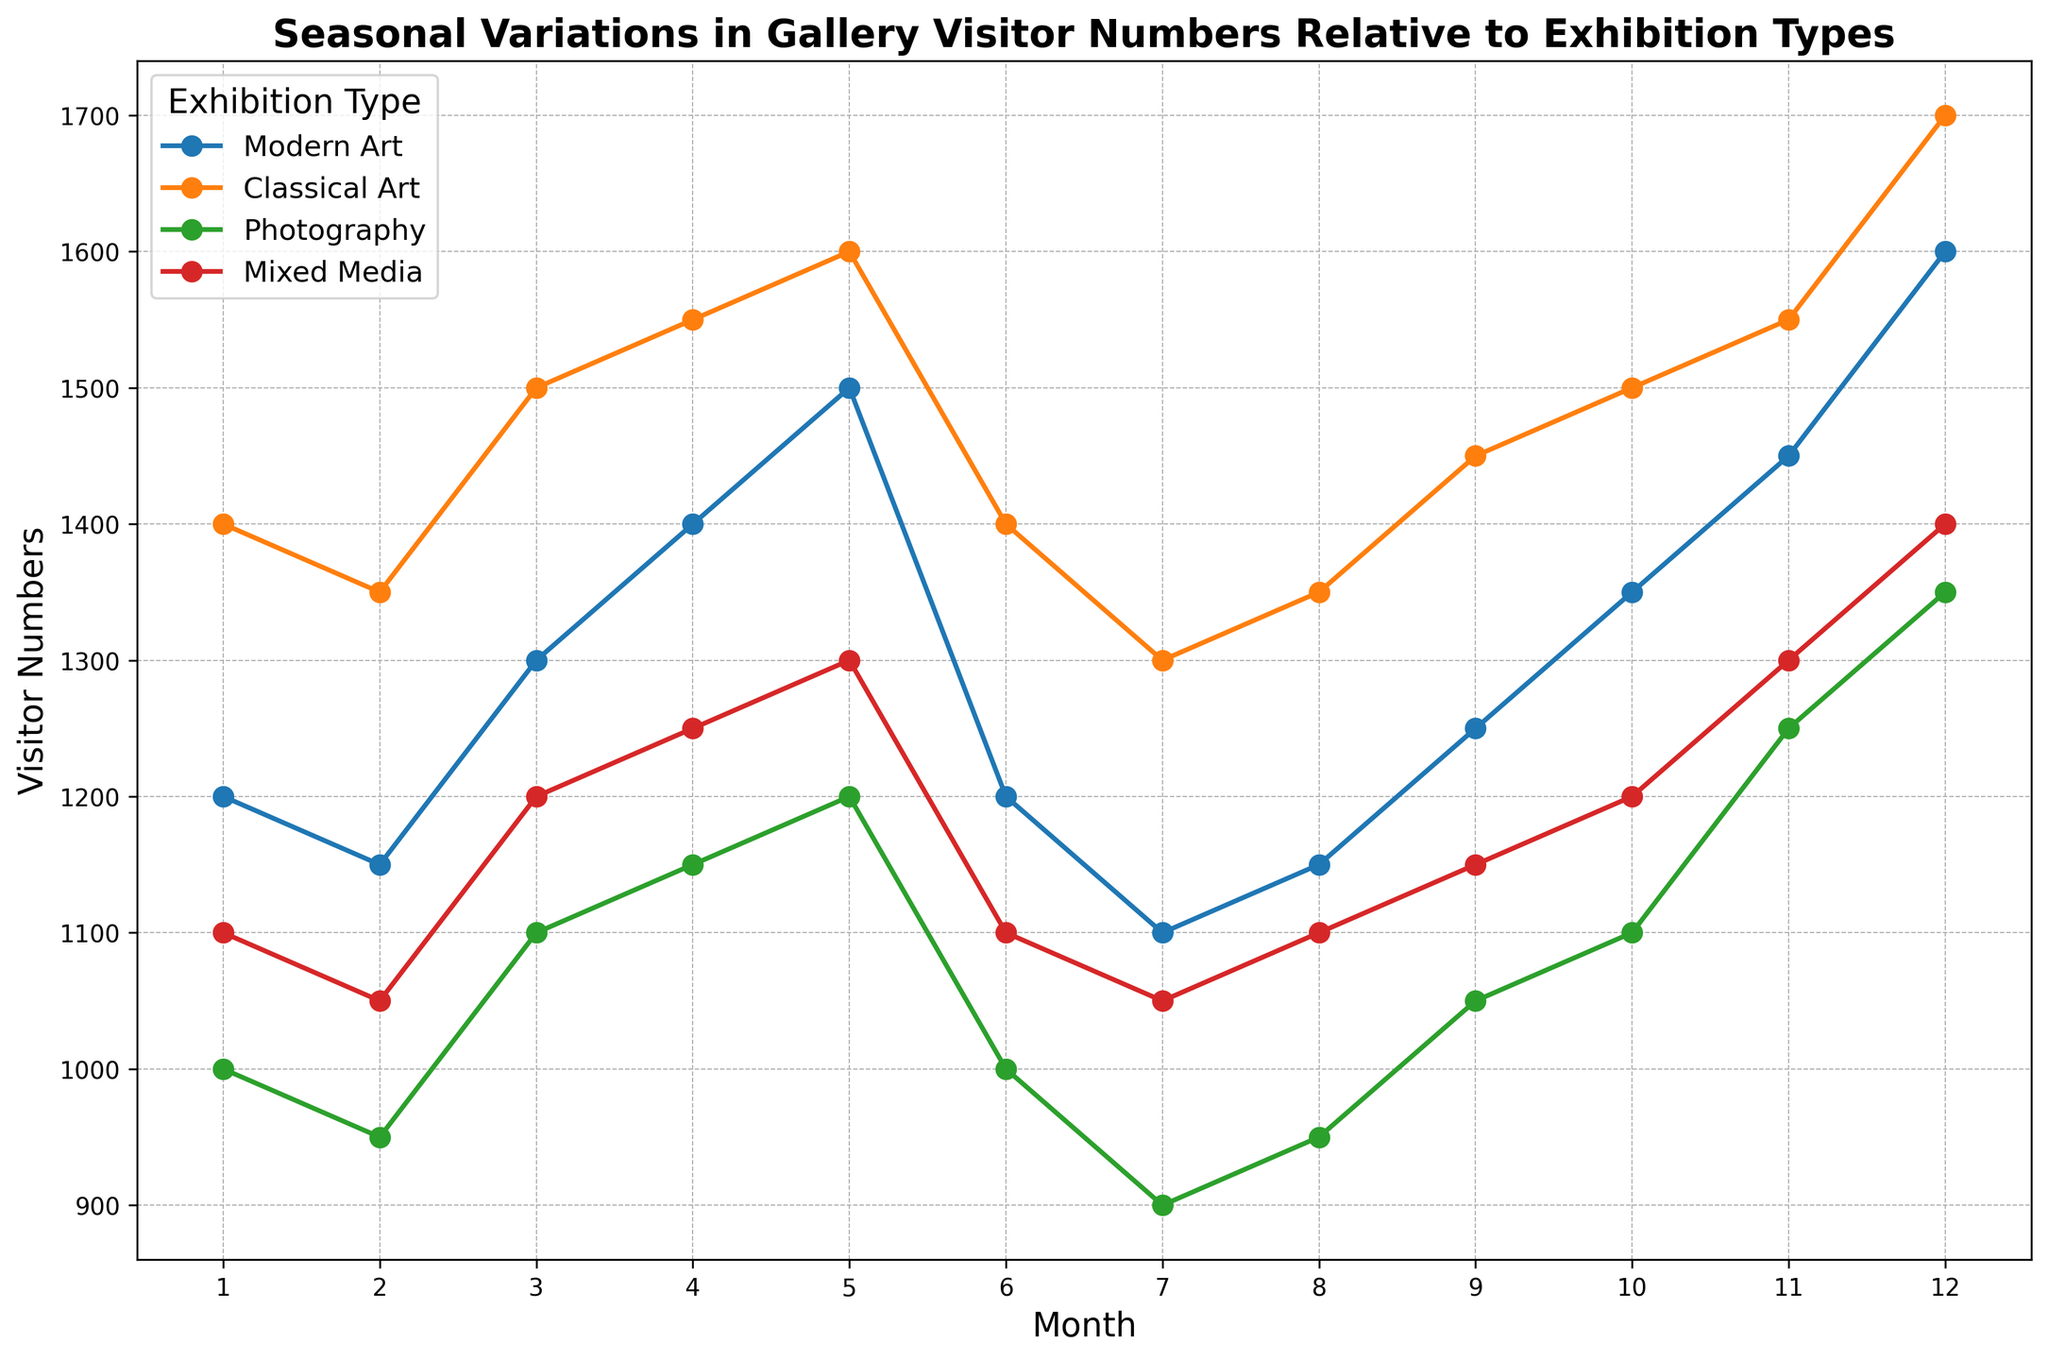what month had the highest visitor numbers for Modern Art? To identify the month with the highest visitor numbers for Modern Art, look at the Modern Art plot line and find the peak. The highest value for Modern Art (1600 visitors) is in December.
Answer: December what is the difference between the maximum visitor numbers of Classical Art and Photography? To find the difference, subtract the maximum visitor numbers of Photography (1350 in December) from the maximum of Classical Art (1700 in December). The calculation is 1700 - 1350.
Answer: 350 what is the average visitor number for Mixed Media exhibitions in the first quarter (Jan-Mar)? To calculate the average, sum the visitor numbers for Mixed Media in January, February, and March, and then divide by 3. The numbers are 1100, 1050, and 1200. So, (1100 + 1050 + 1200) / 3 = 1116.67
Answer: 1116.67 which exhibition type shows the greatest overall variability in visitor numbers throughout the year? To determine variability, compare the range (difference between the highest and lowest visitor numbers) for each type. Classical Art varies from 1300 to 1700, Modern Art from 1100 to 1600, Photography from 900 to 1350, and Mixed Media from 1050 to 1400. Classical Art has the largest range of 400 (1700 - 1300).
Answer: Classical Art how does the visitor trend for Photography compare to Modern Art over the summer months (Jun-Aug)? Look at the visitor numbers for June, July, and August for both Photography and Modern Art. Photography shows a consistent number of around 950-1000, while Modern Art decreases from 1200 to 1100 and then to 1150. Photography remains stable, whereas Modern Art shows a slight decline and recovery.
Answer: Photography is stable, Modern Art declines then recovers which months did all exhibition types experience an increase in visitor numbers compared to the previous month? Check each month-to-month transition for increases across all types. From March to April, all exhibition types show growth in visitor numbers.
Answer: March to April which exhibition type had the most visitors in a single month throughout the year? Identify the highest single visitor number for any exhibition type by finding the peak values. Classical Art had the most visitors in December with 1700.
Answer: Classical Art compare the lowest visitor numbers of Modern Art and Mixed Media. Identify the lowest visitor numbers for Modern Art (1100 in July) and Mixed Media (1050 in February and July). Mixed Media has a lower minimum compared to Modern Art.
Answer: Mixed Media between which months do Modern Art exhibitions see the highest month-over-month increase in visitor numbers? Calculate the month-over-month increase in visitor numbers for Modern Art. The largest increase is from November (1450) to December (1600) with an increase of 150 visitors.
Answer: November to December what is the total number of visitors for Classical Art exhibitions in the second half of the year (Jul-Dec)? Sum the visitor numbers for Classical Art from July to December. The numbers are 1300, 1350, 1450, 1500, 1550, 1700. So, 1300 + 1350 + 1450 + 1500 + 1550 + 1700 = 8850.
Answer: 8850 